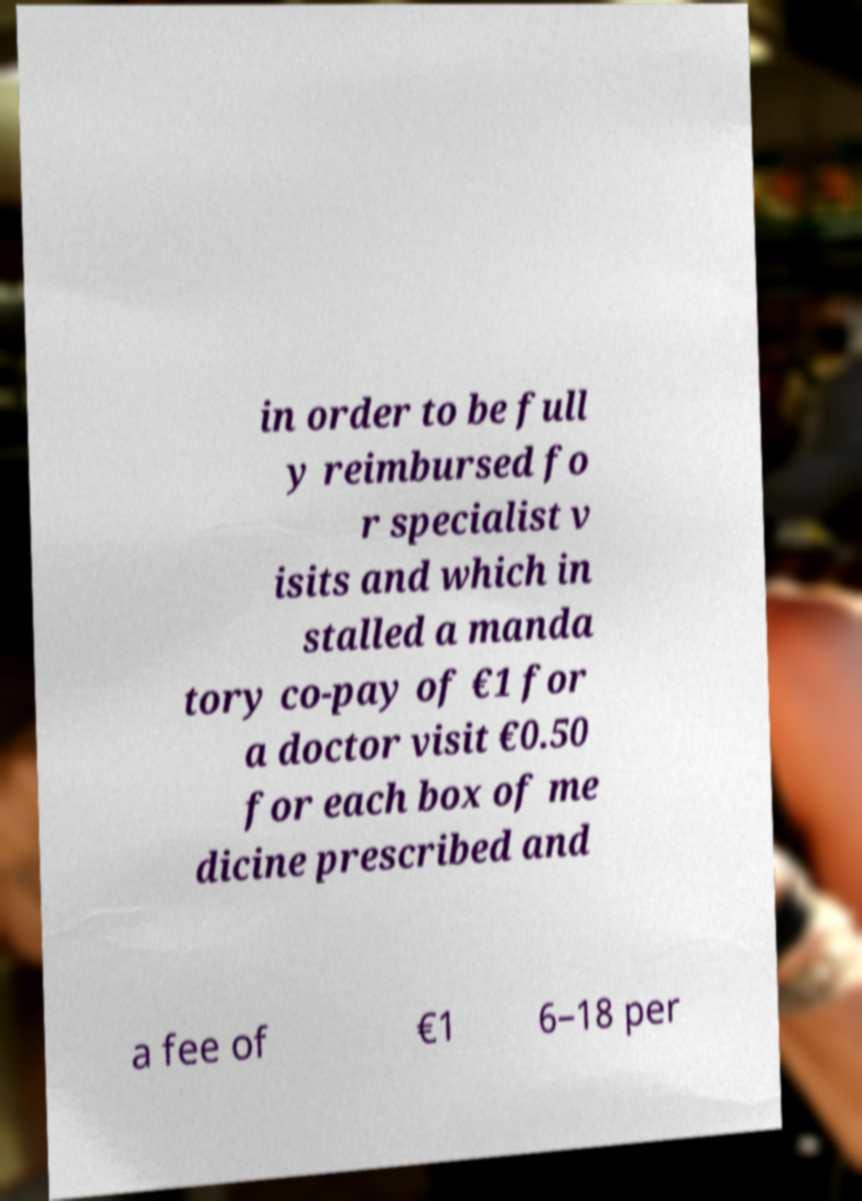Please identify and transcribe the text found in this image. in order to be full y reimbursed fo r specialist v isits and which in stalled a manda tory co-pay of €1 for a doctor visit €0.50 for each box of me dicine prescribed and a fee of €1 6–18 per 